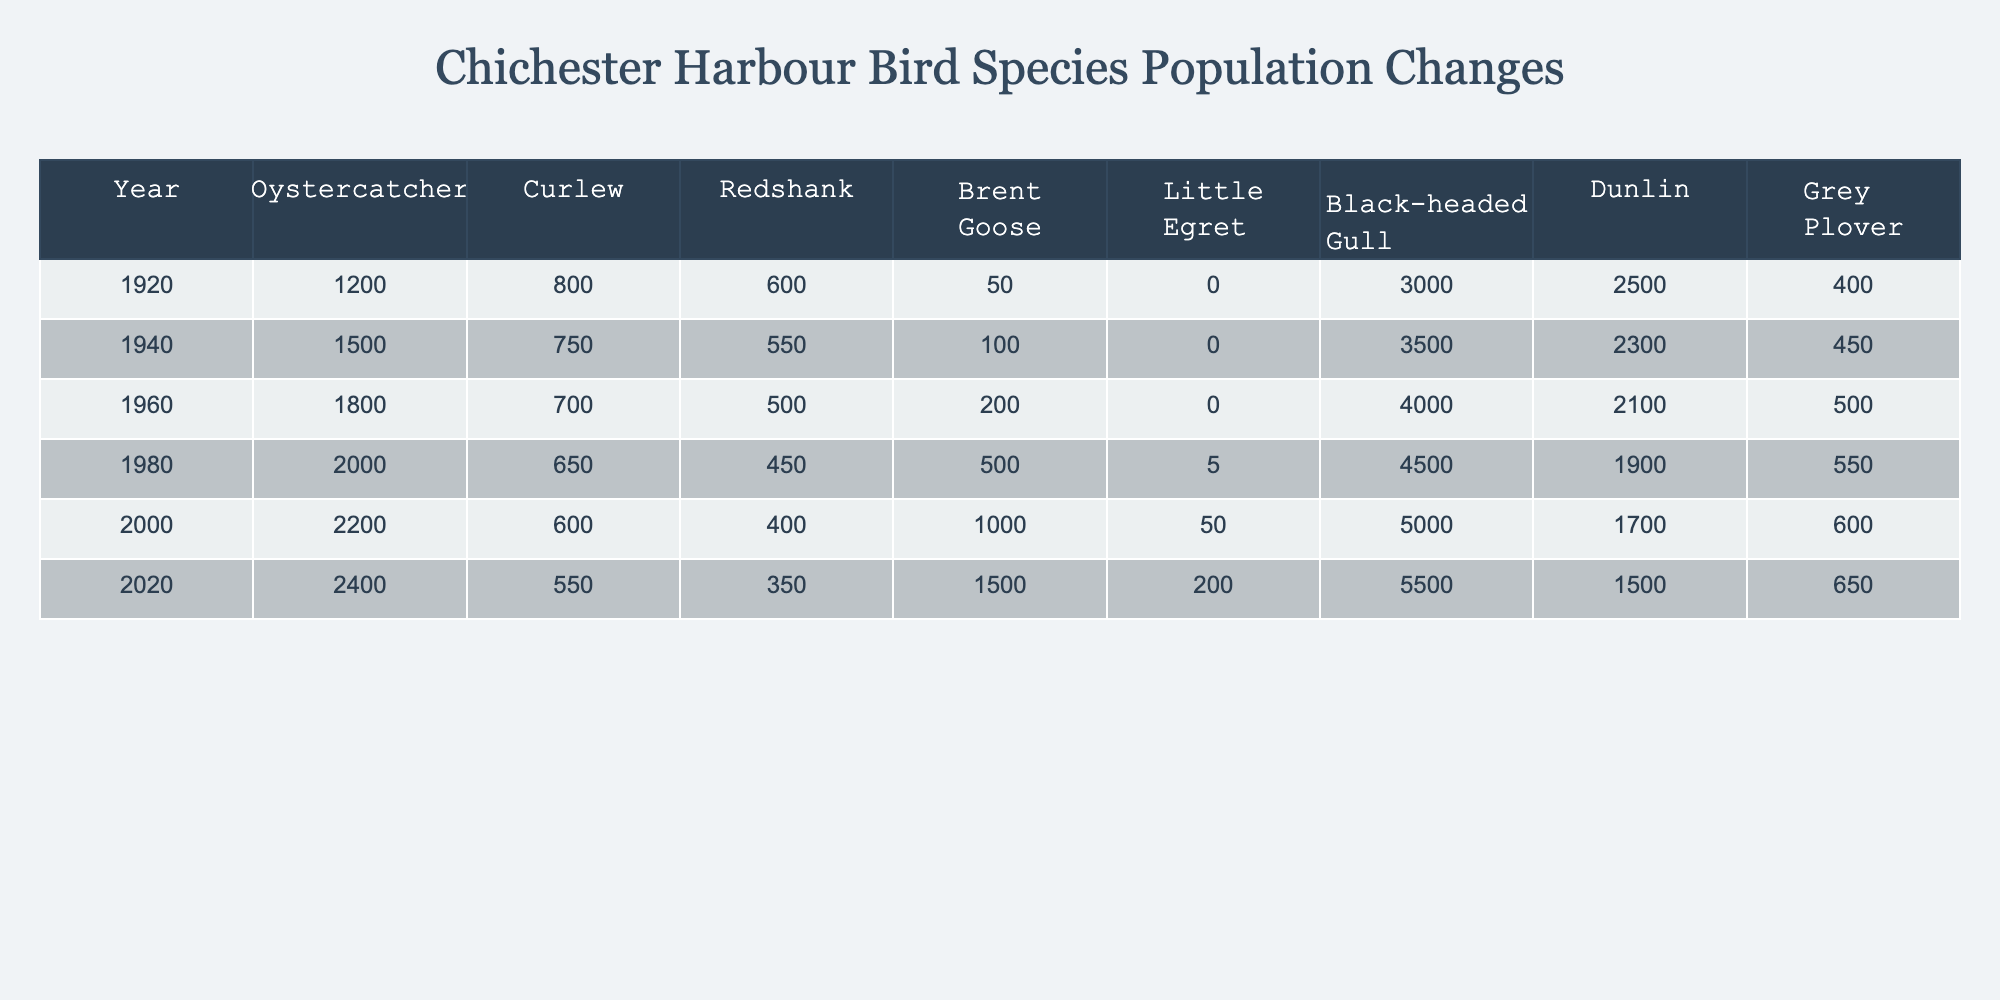What was the population of Oystercatchers in the year 1960? Referring to the table, the row for the year 1960 indicates that the population of Oystercatchers was 1800.
Answer: 1800 What was the population change of Black-headed Gulls from 1920 to 2020? In 1920, the population of Black-headed Gulls was 3000, and in 2020 it was 5500. The change can be calculated as 5500 - 3000 = 2500.
Answer: 2500 Which bird species had the highest population in 1980? In the table, the populations of various species in 1980 show that Oystercatchers had the highest population of 2000.
Answer: Oystercatcher Is the population of Curlews decreasing over time based on this data? Observing the population of Curlews from 1920 (800) to 2020 (550), we see a decline over this period. Thus, yes, the population is decreasing.
Answer: Yes What is the average population of Dunlins from 1920 to 2020? The populations of Dunlins for the years provided are 2500, 3500, 4000, 4500, 5000, and 5500. To find the average, we sum these values (2500 + 3500 + 4000 + 4500 + 5000 + 5500 = 29500) and divide by 6, giving us an average of 4916.67.
Answer: 4917 How much did the population of Grey Plovers decrease from 1920 to 2020? The populations for Grey Plovers in 1920 and 2020 were 400 and 1500, respectively. Since there is an increase, we find it as 1500 - 400 = 1100.
Answer: 1100 In which year did the Brent Goose population first reach 1000? Referring to the table, Brent Goose populations were 50, 100, 200, 500, 1000, and 1500 over the years. The first instance of 1000 was in the year 2000.
Answer: 2000 Was the population of Little Egrets non-existent in 1920? From the table, the population of Little Egrets in 1920 is listed as 0, indicating that they did not exist in measurable numbers at that time.
Answer: Yes Which bird species experienced the greatest percentage increase in population from 1920 to 2020? For Oystercatchers, the population increased from 1200 to 2400, a percentage increase of 100%. For Curlews, from 800 to 550, a decrease, and so on. The largest percentage increase is from 1200 to 2400 for Oystercatchers.
Answer: Oystercatcher If you add the populations of Curlew and Redshank in 2000, what is the total? In 2000, the population of Curlews was 600 and of Redshanks was 400. Adding these together gives 600 + 400 = 1000.
Answer: 1000 